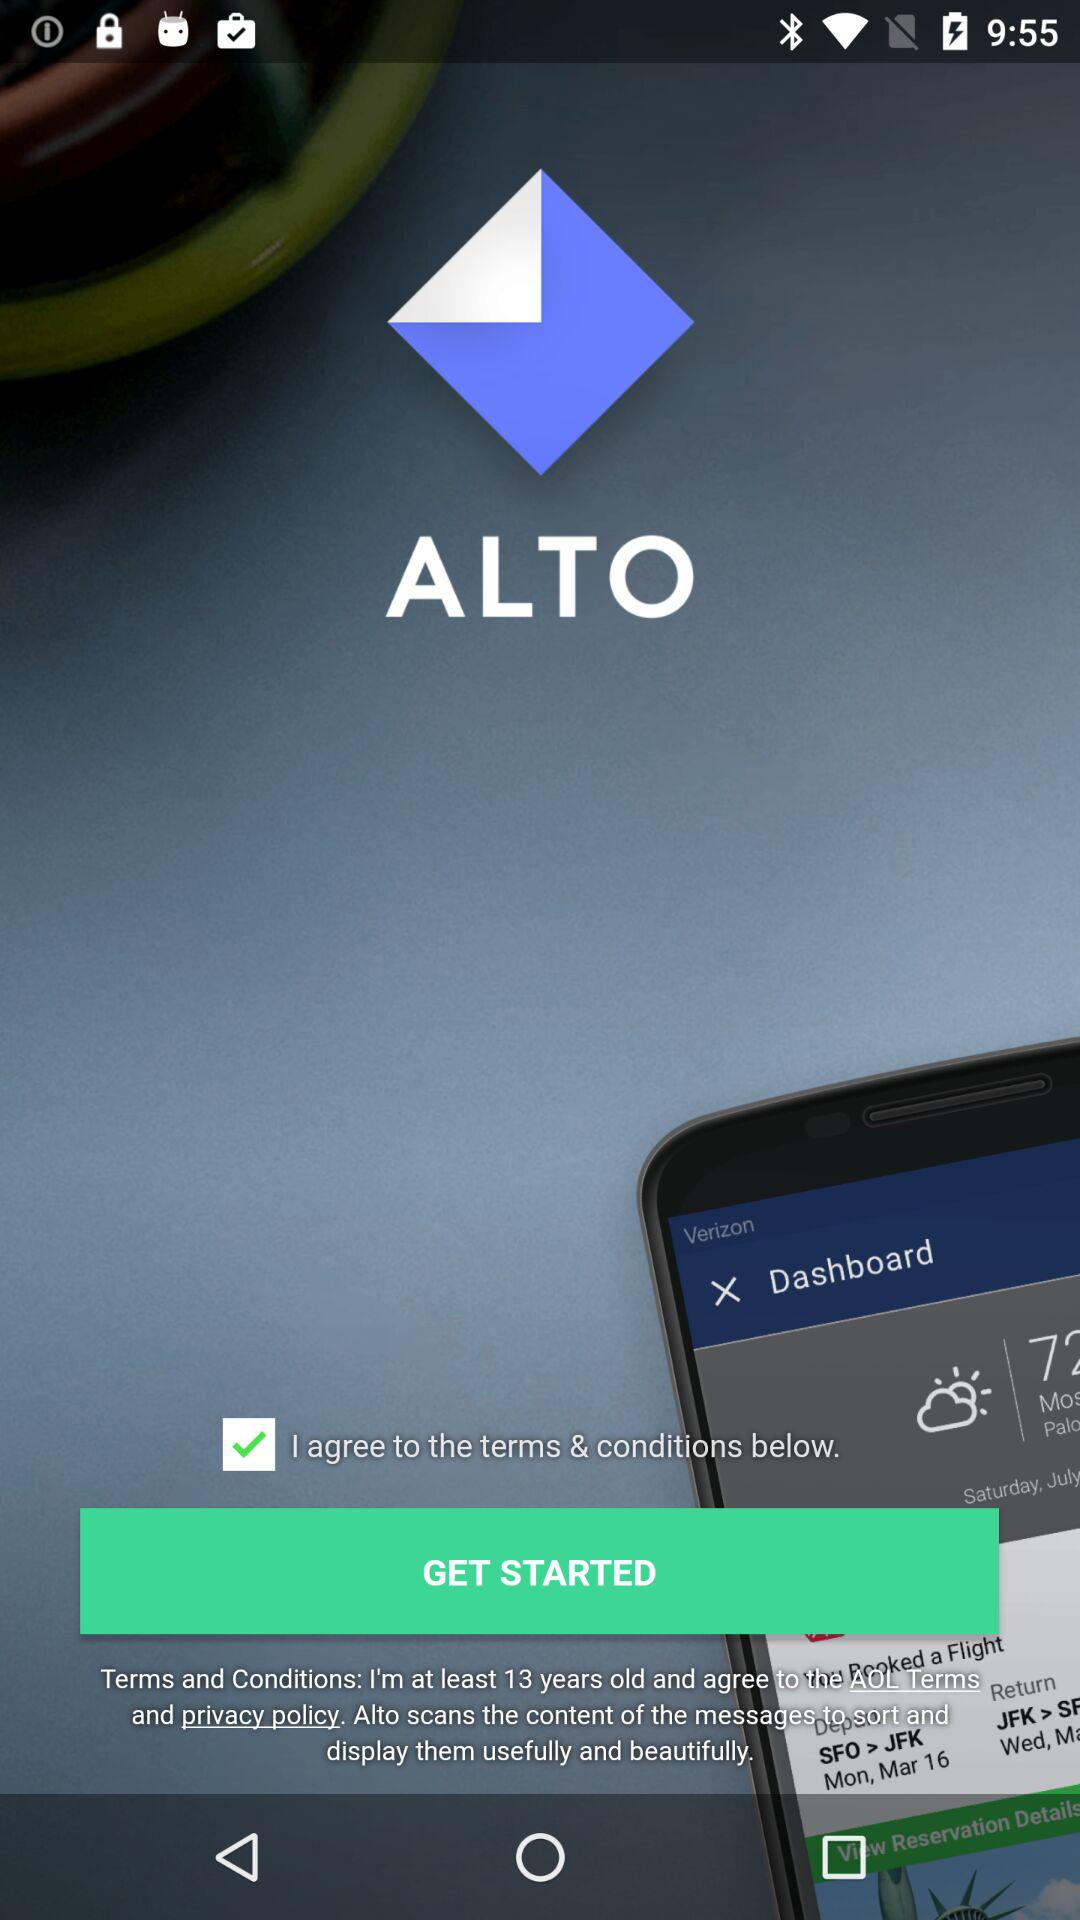What is the application name? The application name is "ALTO". 